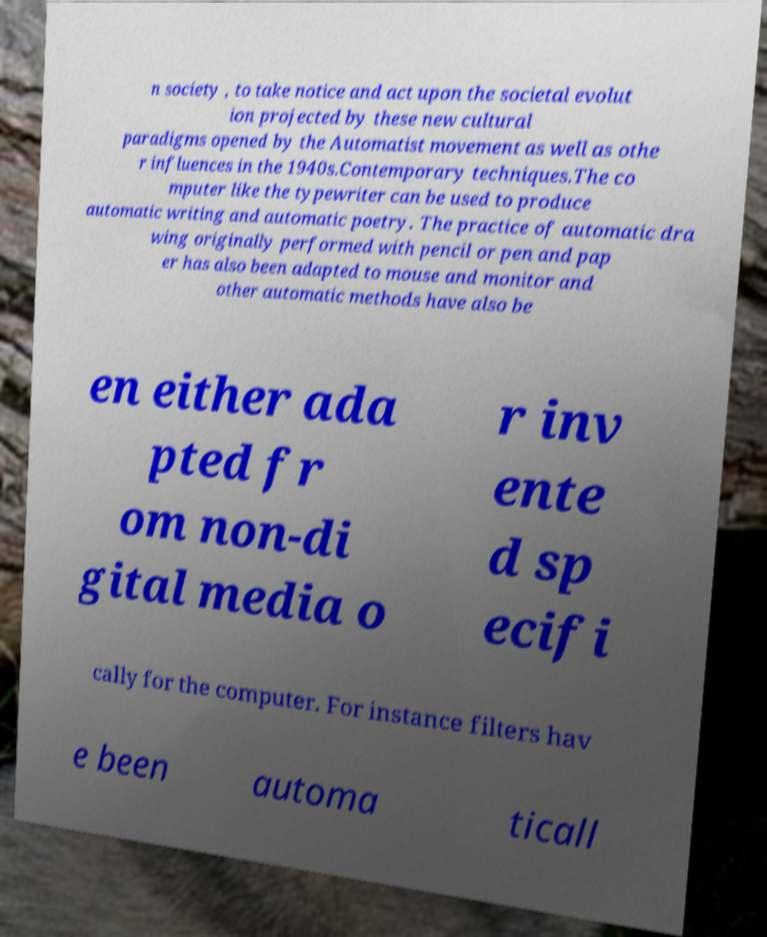Could you assist in decoding the text presented in this image and type it out clearly? n society , to take notice and act upon the societal evolut ion projected by these new cultural paradigms opened by the Automatist movement as well as othe r influences in the 1940s.Contemporary techniques.The co mputer like the typewriter can be used to produce automatic writing and automatic poetry. The practice of automatic dra wing originally performed with pencil or pen and pap er has also been adapted to mouse and monitor and other automatic methods have also be en either ada pted fr om non-di gital media o r inv ente d sp ecifi cally for the computer. For instance filters hav e been automa ticall 